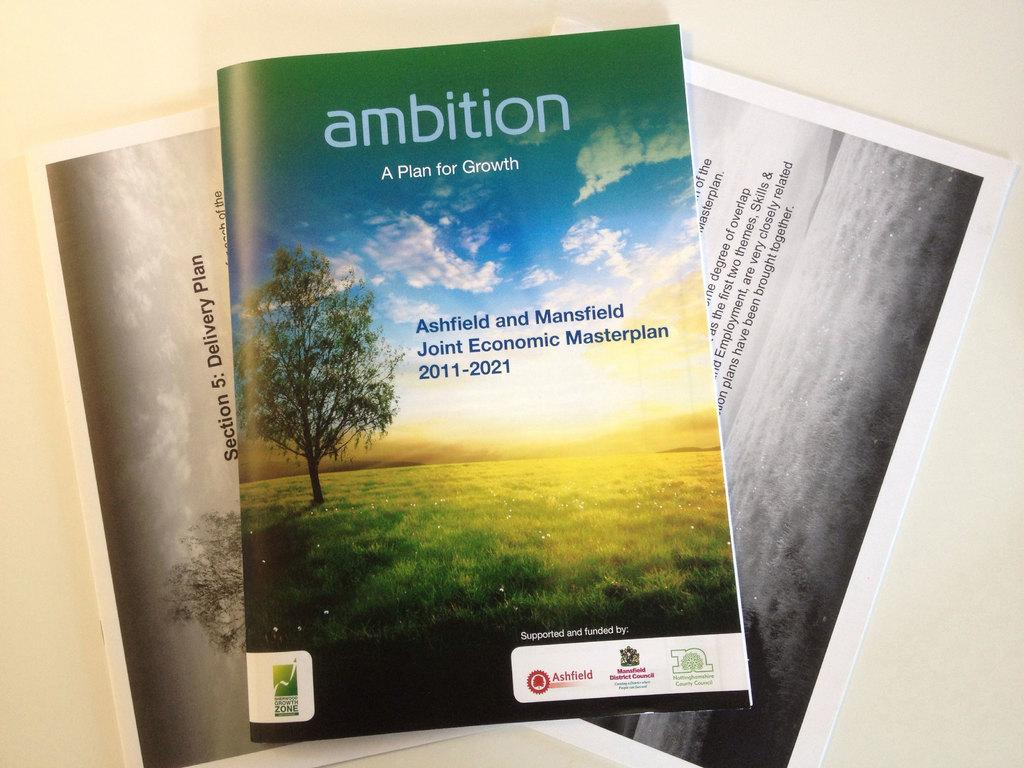<image>
Write a terse but informative summary of the picture. A green magazine that is titled Ambition: a plan for growth. 